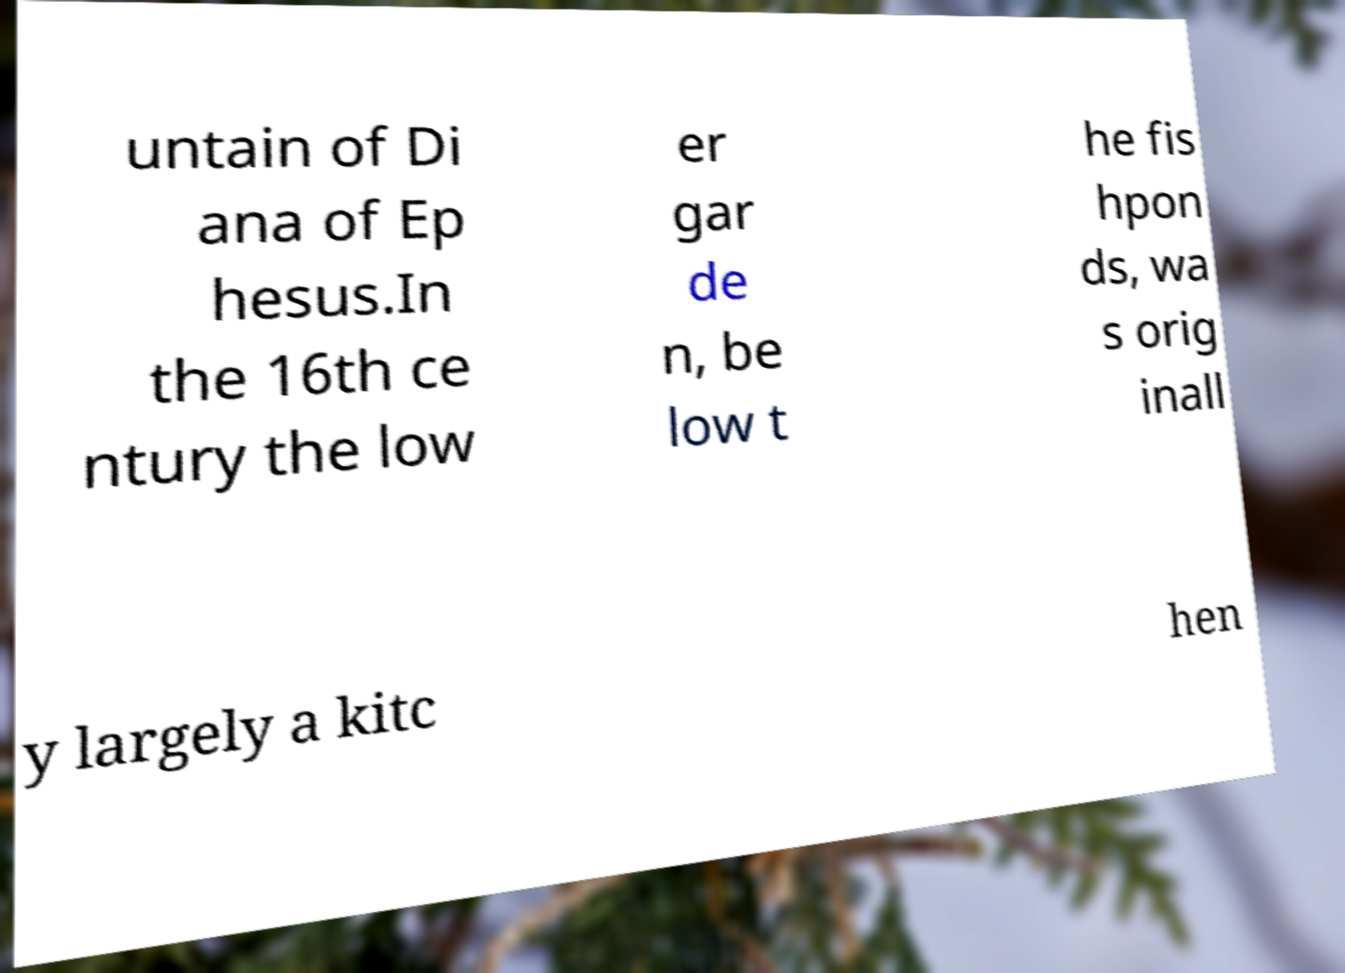Could you assist in decoding the text presented in this image and type it out clearly? untain of Di ana of Ep hesus.In the 16th ce ntury the low er gar de n, be low t he fis hpon ds, wa s orig inall y largely a kitc hen 